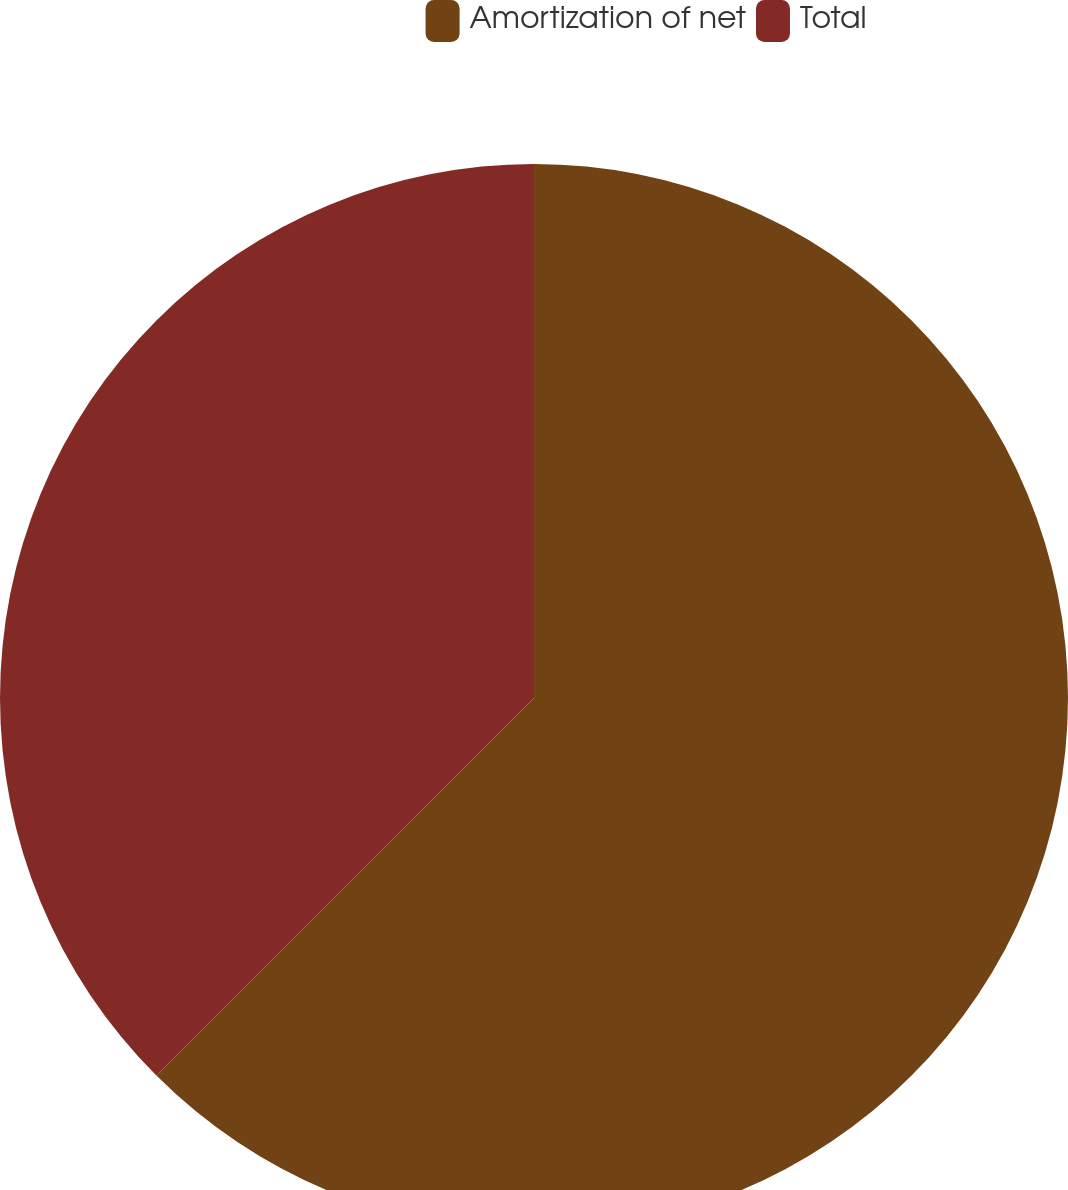Convert chart. <chart><loc_0><loc_0><loc_500><loc_500><pie_chart><fcel>Amortization of net<fcel>Total<nl><fcel>62.5%<fcel>37.5%<nl></chart> 